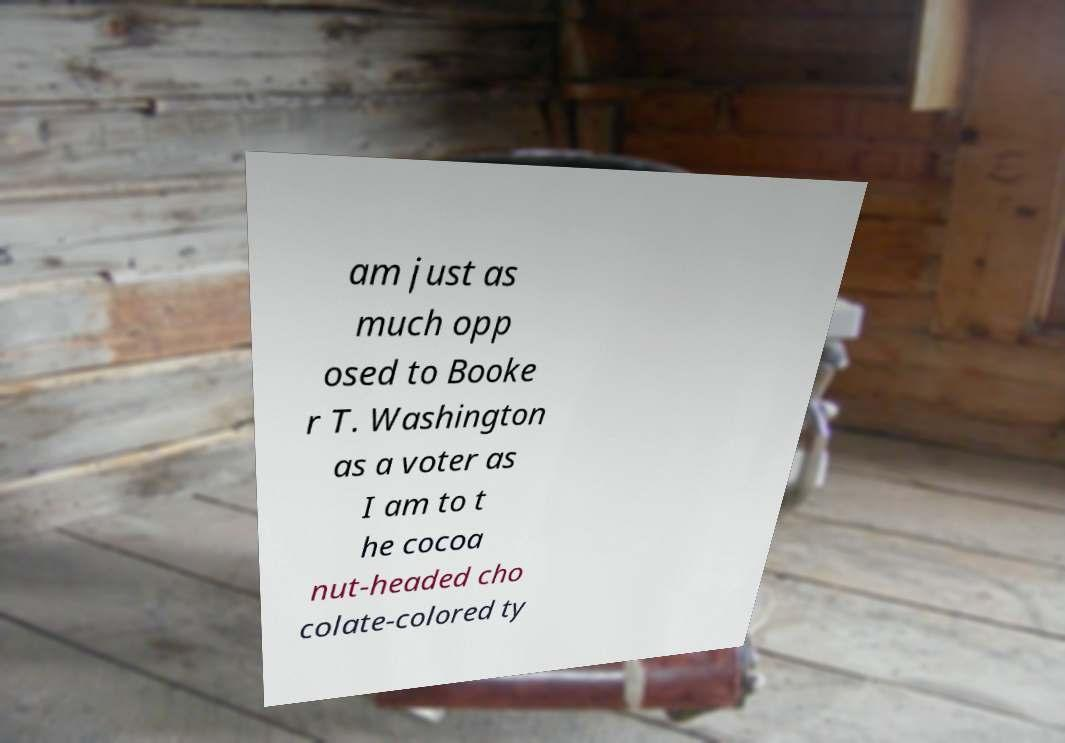For documentation purposes, I need the text within this image transcribed. Could you provide that? am just as much opp osed to Booke r T. Washington as a voter as I am to t he cocoa nut-headed cho colate-colored ty 